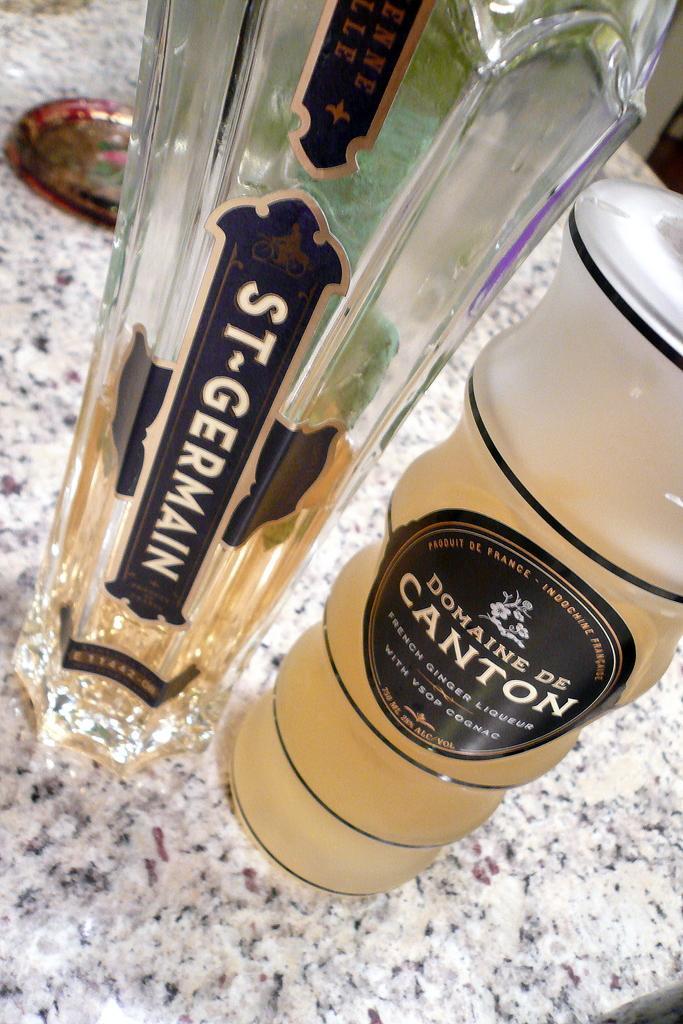Could you give a brief overview of what you see in this image? In this picture we can see bottle with sticker to it and a glass with drink in it and this two are placed on a floor and in background we can see some plate. 